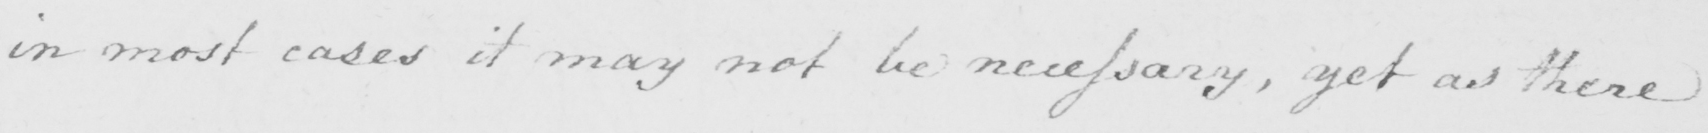Can you read and transcribe this handwriting? in most cases it may not be necessary  , yet as there 